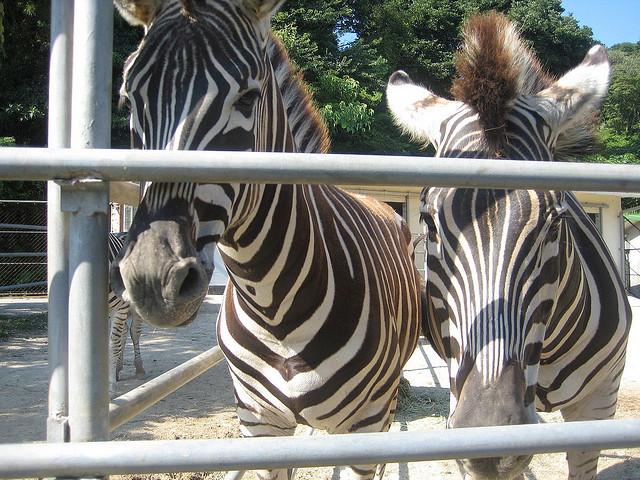What are the zebra in?
Be succinct. Pen. How many stripes on the zebras?
Answer briefly. Many. Are these animals in their natural environment?
Answer briefly. No. 